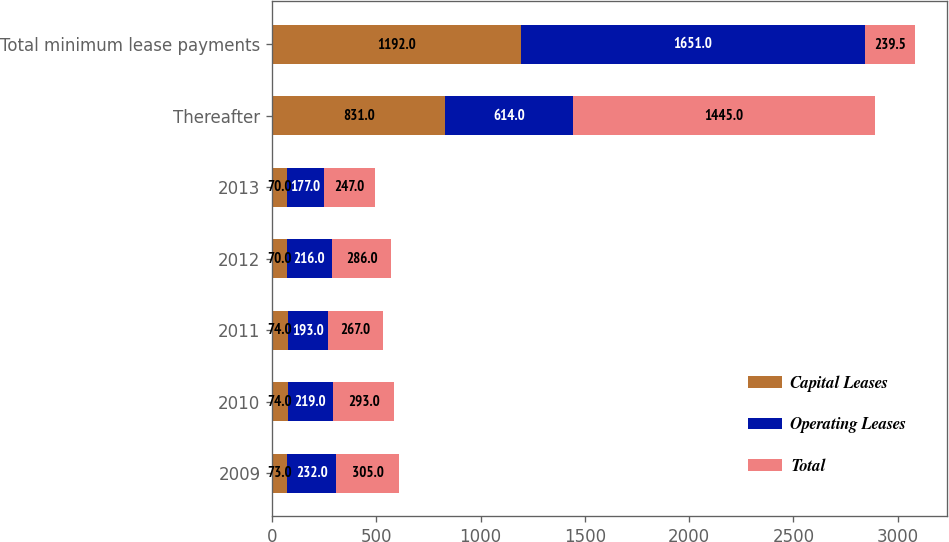Convert chart. <chart><loc_0><loc_0><loc_500><loc_500><stacked_bar_chart><ecel><fcel>2009<fcel>2010<fcel>2011<fcel>2012<fcel>2013<fcel>Thereafter<fcel>Total minimum lease payments<nl><fcel>Capital Leases<fcel>73<fcel>74<fcel>74<fcel>70<fcel>70<fcel>831<fcel>1192<nl><fcel>Operating Leases<fcel>232<fcel>219<fcel>193<fcel>216<fcel>177<fcel>614<fcel>1651<nl><fcel>Total<fcel>305<fcel>293<fcel>267<fcel>286<fcel>247<fcel>1445<fcel>239.5<nl></chart> 